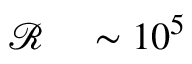<formula> <loc_0><loc_0><loc_500><loc_500>\begin{array} { r l } { \mathcal { R } } & \sim 1 0 ^ { 5 } } \end{array}</formula> 